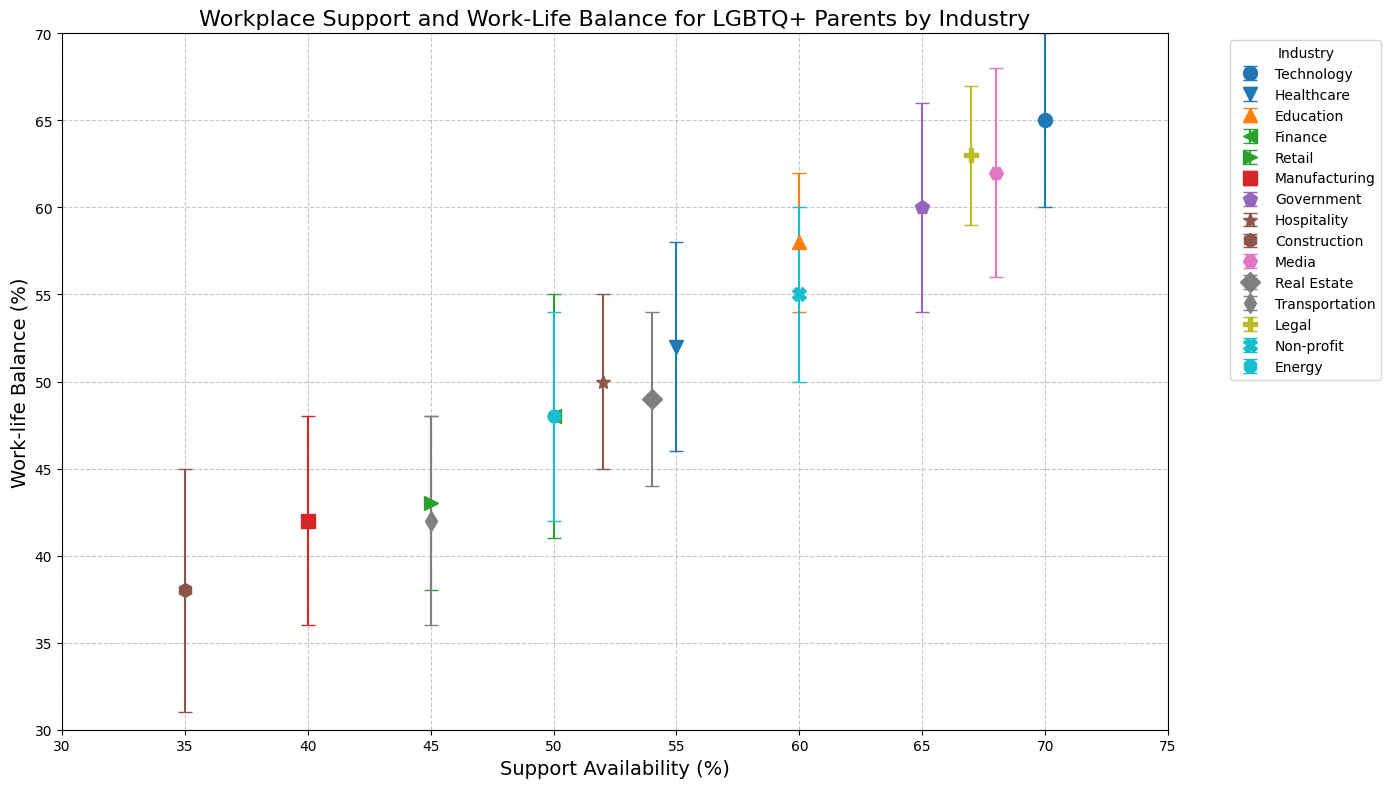What industry has the highest work-life balance percentage? The industry with the highest work-life balance percentage is determined by finding the highest value along the y-axis. In this case, it corresponds to the Technology industry with 65%.
Answer: Technology Which industry has the lowest support availability percentage? The industry with the lowest support availability percentage can be found by identifying the lowest value along the x-axis. Here, it is the Construction industry with 35%.
Answer: Construction Compare the work-life balance percentages of the Media and Legal industries. Which one is higher and by how much? To compare, look at the y-axis values for Media and Legal. Media has 62% and Legal has 63%. The difference is 63% - 62% = 1%.
Answer: Legal, by 1% How does the work-life balance in the Healthcare industry compare with that in Hospitality? Notice the y-axis values: Healthcare is at 52% and Hospitality is at 50%. Therefore, Healthcare has a 2% higher work-life balance than Hospitality.
Answer: Healthcare, by 2% What is the average support availability percentage for the Technology, Healthcare, and Education industries? Sum the support availability percentages for these industries: Technology (70) + Healthcare (55) + Education (60) = 185. Divide by 3, getting an average of 185 / 3 ≈ 61.67.
Answer: 61.67 Which industry has the highest standard deviation, and what is its value? The highest standard deviation is determined by finding the maximum value in the Standard Deviation column. Finance and Construction both have the highest standard deviation of 7.
Answer: Finance and Construction, 7 Identify the industries with standard deviation values greater than 5. Check each industry’s standard deviation: Healthcare (6), Finance (7), Manufacturing (6), Government (6), Media (6), Construction (7), Transportation (6), and Energy (6) have standard deviations greater than 5.
Answer: Healthcare, Finance, Manufacturing, Government, Media, Construction, Transportation, Energy Between the Education and Non-profit industries, which one has a higher support availability percentage and by how much? Education has a support availability of 60%, and Non-profit has 60%. The difference is 0%.
Answer: Same, 0% How does the support availability in the Retail industry compare to that in the Real Estate industry? Compare the x-axis values: Retail has 45%, and Real Estate has 54%. Thus, Real Estate’s support availability is higher by 54% - 45% = 9%.
Answer: Real Estate, by 9% Which industry has a higher work-life balance percentage, Manufacturing or Transportation? Check the y-axis values for Manufacturing (42%) and Transportation (42%). Both are the same.
Answer: Same 